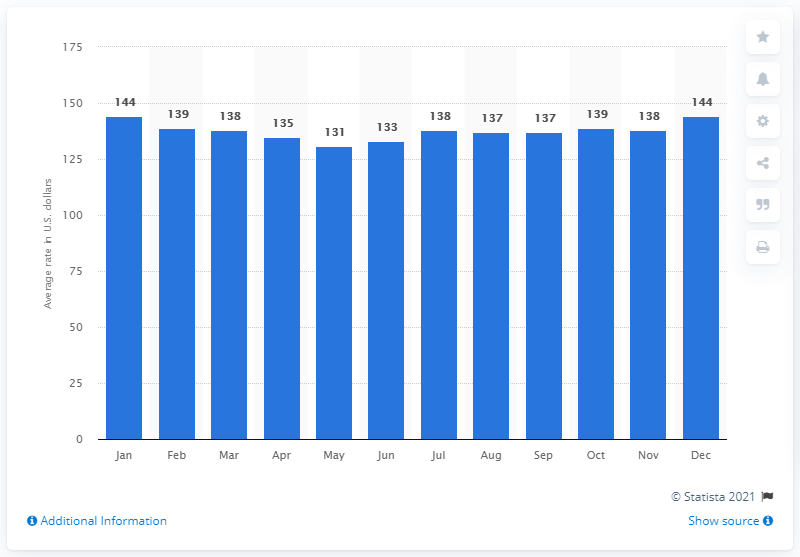Draw attention to some important aspects in this diagram. In January and December 2015, the average hotel rate in Australia was approximately $144 in US dollars per night. 